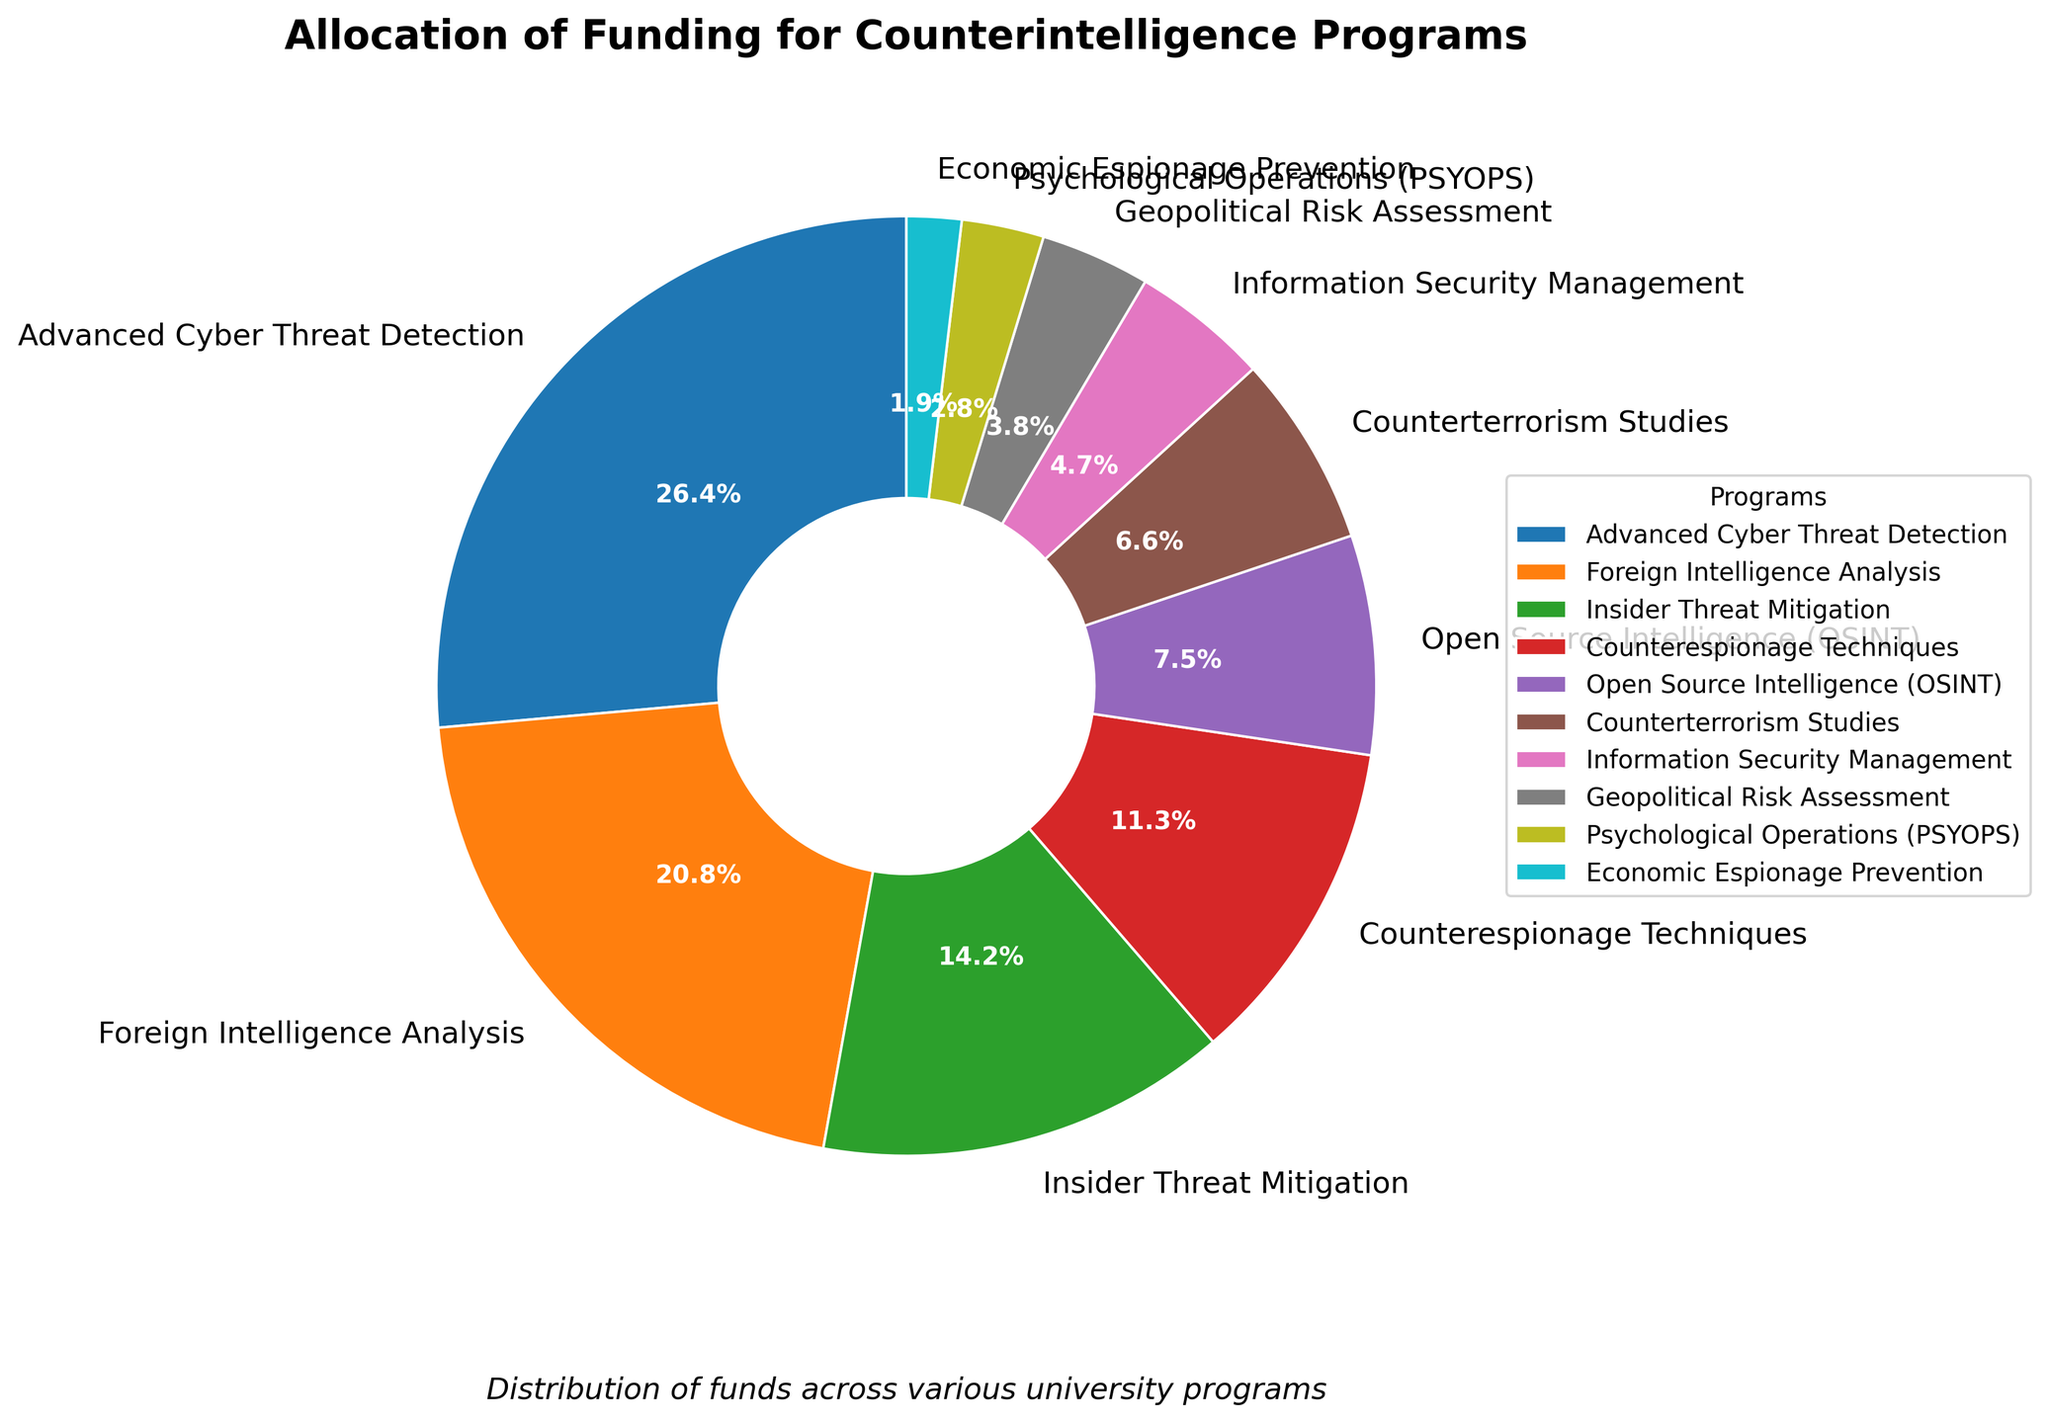What percentage of the total funding is allocated to Advanced Cyber Threat Detection and Foreign Intelligence Analysis combined? First, look at the percentage for Advanced Cyber Threat Detection, which is 28%. Then look at the percentage for Foreign Intelligence Analysis, which is 22%. Add these two percentages together: 28% + 22% = 50%
Answer: 50% Which program has the least amount of funding allocated and what percentage of the total funding does it receive? Look at the pie chart segments and identify the smallest segment. The smallest segment corresponds to Economic Espionage Prevention, which has a funding allocation of 2%.
Answer: Economic Espionage Prevention, 2% Is the funding for Counterterrorism Studies greater than the funding for OSINT and Psychological Operations combined? Look at the percentages for Counterterrorism Studies (7%), OSINT (8%), and Psychological Operations (3%). Summing OSINT and Psychological Operations gives 8% + 3% = 11%. Since 7% (Counterterrorism Studies) is less than 11%, the answer is No.
Answer: No Which program has the highest funding allocation, and what percentage of the total funding does it receive? Look at the pie chart and identify the largest segment, which corresponds to Advanced Cyber Threat Detection. It has a funding allocation of 28%.
Answer: Advanced Cyber Threat Detection, 28% How much more funding percentage does Insider Threat Mitigation have compared to Information Security Management? Look at the percentages for Insider Threat Mitigation (15%) and Information Security Management (5%). Subtract the latter from the former: 15% - 5% = 10%.
Answer: 10% What is the total percentage of funding allocated to programs related to intelligence (Advanced Cyber Threat Detection, Foreign Intelligence Analysis, Open Source Intelligence)? Add the percentages for Advanced Cyber Threat Detection (28%), Foreign Intelligence Analysis (22%), and Open Source Intelligence (8%): 28% + 22% + 8% = 58%.
Answer: 58% Between Geopolitical Risk Assessment and Psychological Operations, which program receives more funding and by what margin? Compare the percentages for Geopolitical Risk Assessment (4%) and Psychological Operations (3%). Subtract the smaller from the larger: 4% - 3% = 1%.
Answer: Geopolitical Risk Assessment, 1% How do the funding allocations for Counterespionage Techniques and Counterterrorism Studies differ visually? Identify the color and size of the segments in the pie chart for Counterespionage Techniques (12%) and Counterterrorism Studies (7%). Counterespionage Techniques has a larger segment and is represented by a visually larger slice.
Answer: Counterespionage Techniques has a larger segment What is the combined funding allocation for the two smallest programs? Identify the two smallest segments, which are Economic Espionage Prevention (2%) and Psychological Operations (3%). Add these percentages together: 2% + 3% = 5%.
Answer: 5% 